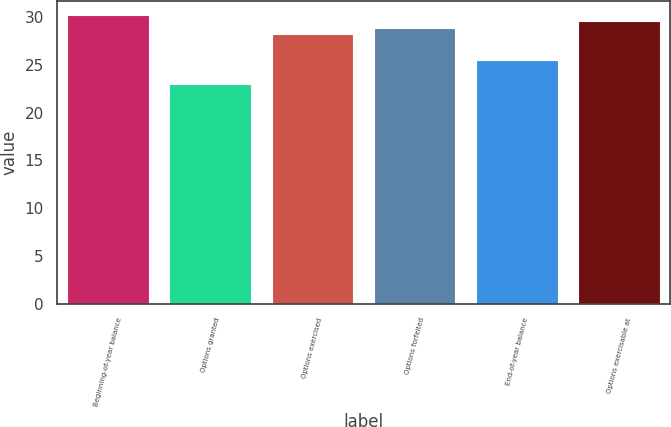Convert chart. <chart><loc_0><loc_0><loc_500><loc_500><bar_chart><fcel>Beginning-of-year balance<fcel>Options granted<fcel>Options exercised<fcel>Options forfeited<fcel>End-of-year balance<fcel>Options exercisable at<nl><fcel>30.21<fcel>22.98<fcel>28.26<fcel>28.91<fcel>25.52<fcel>29.56<nl></chart> 